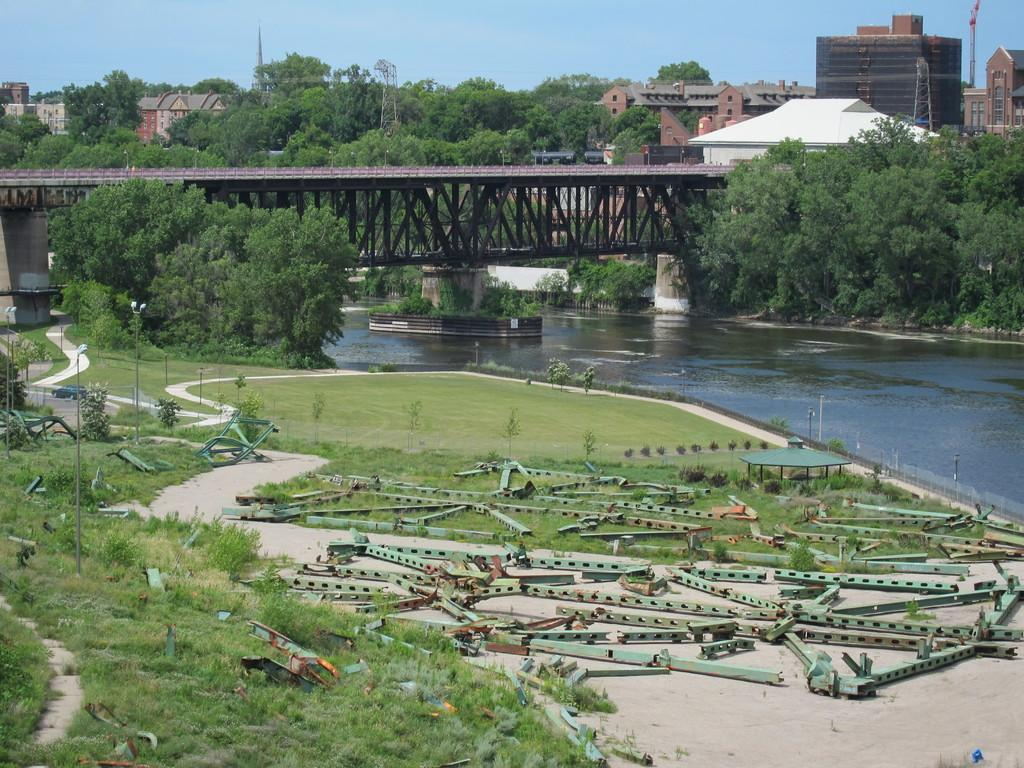What objects can be seen in the foreground of the image? There are iron rods and grass in the foreground of the image. What natural feature is present in the image? There is a water body in the image. What man-made structure can be seen in the image? There is a bridge in the image. What type of vegetation is visible in the background of the image? There are trees in the background of the image. What type of buildings can be seen in the background of the image? There are buildings in the background of the image. What part of the natural environment is visible in the background of the image? The sky is visible in the background of the image. Can you tell me how many deer are visible on the bridge in the image? There are no deer present in the image; the bridge is the only man-made structure visible. What type of key is used to unlock the water body in the image? There is no key or locking mechanism present in the image; the water body is a natural feature. 